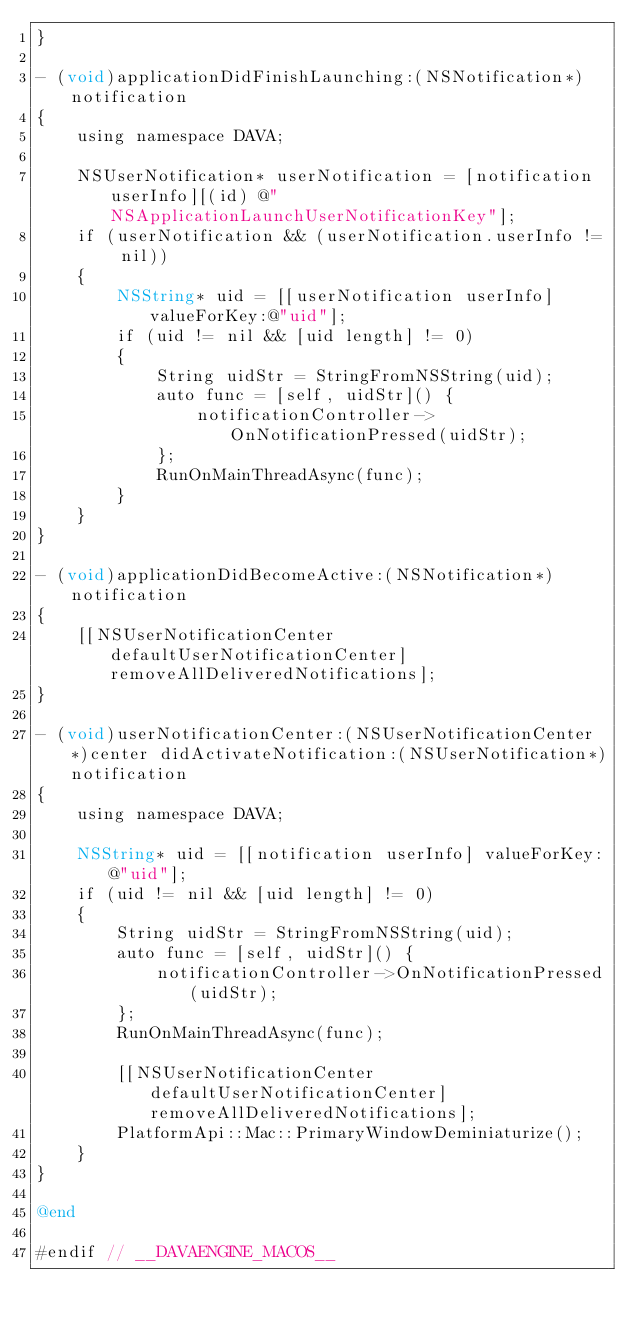<code> <loc_0><loc_0><loc_500><loc_500><_ObjectiveC_>}

- (void)applicationDidFinishLaunching:(NSNotification*)notification
{
    using namespace DAVA;

    NSUserNotification* userNotification = [notification userInfo][(id) @"NSApplicationLaunchUserNotificationKey"];
    if (userNotification && (userNotification.userInfo != nil))
    {
        NSString* uid = [[userNotification userInfo] valueForKey:@"uid"];
        if (uid != nil && [uid length] != 0)
        {
            String uidStr = StringFromNSString(uid);
            auto func = [self, uidStr]() {
                notificationController->OnNotificationPressed(uidStr);
            };
            RunOnMainThreadAsync(func);
        }
    }
}

- (void)applicationDidBecomeActive:(NSNotification*)notification
{
    [[NSUserNotificationCenter defaultUserNotificationCenter] removeAllDeliveredNotifications];
}

- (void)userNotificationCenter:(NSUserNotificationCenter*)center didActivateNotification:(NSUserNotification*)notification
{
    using namespace DAVA;

    NSString* uid = [[notification userInfo] valueForKey:@"uid"];
    if (uid != nil && [uid length] != 0)
    {
        String uidStr = StringFromNSString(uid);
        auto func = [self, uidStr]() {
            notificationController->OnNotificationPressed(uidStr);
        };
        RunOnMainThreadAsync(func);

        [[NSUserNotificationCenter defaultUserNotificationCenter] removeAllDeliveredNotifications];
        PlatformApi::Mac::PrimaryWindowDeminiaturize();
    }
}

@end

#endif // __DAVAENGINE_MACOS__
</code> 